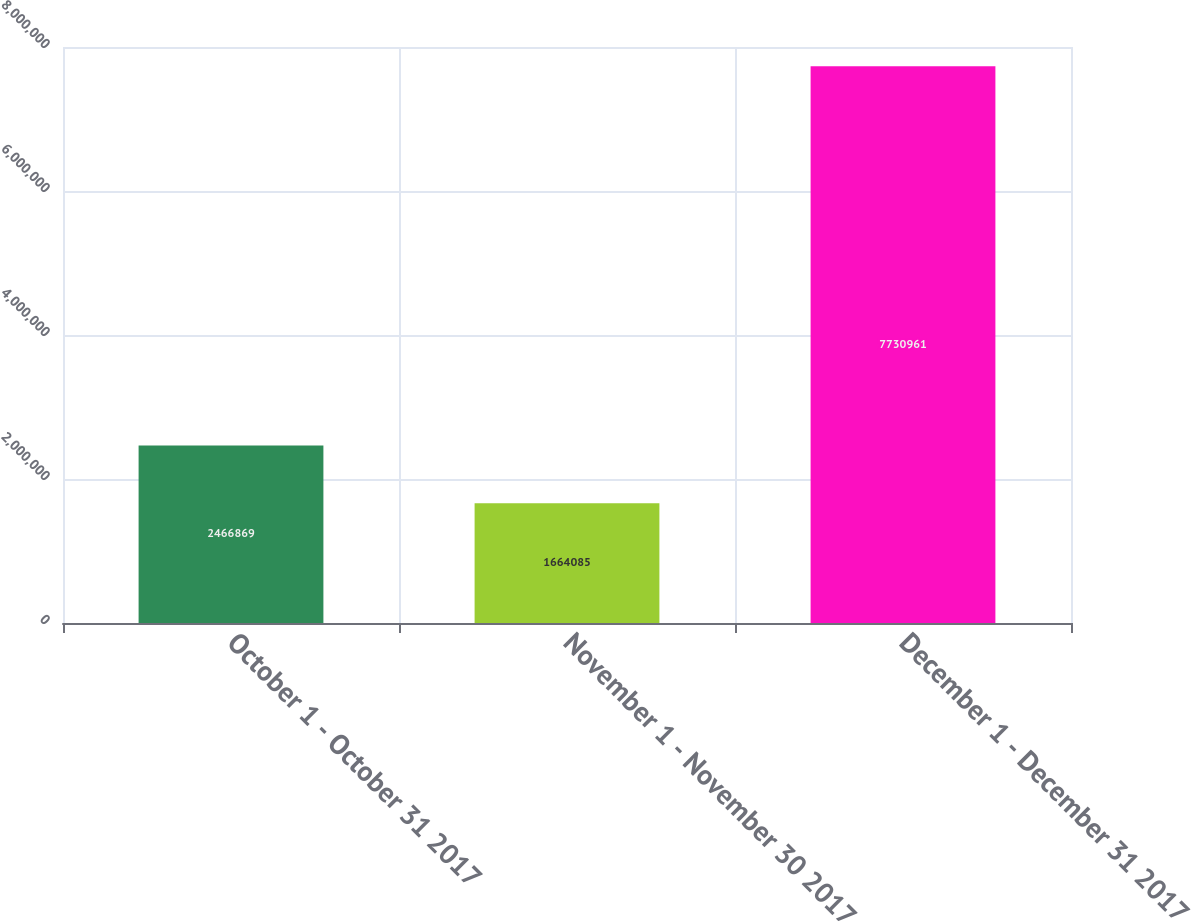Convert chart to OTSL. <chart><loc_0><loc_0><loc_500><loc_500><bar_chart><fcel>October 1 - October 31 2017<fcel>November 1 - November 30 2017<fcel>December 1 - December 31 2017<nl><fcel>2.46687e+06<fcel>1.66408e+06<fcel>7.73096e+06<nl></chart> 